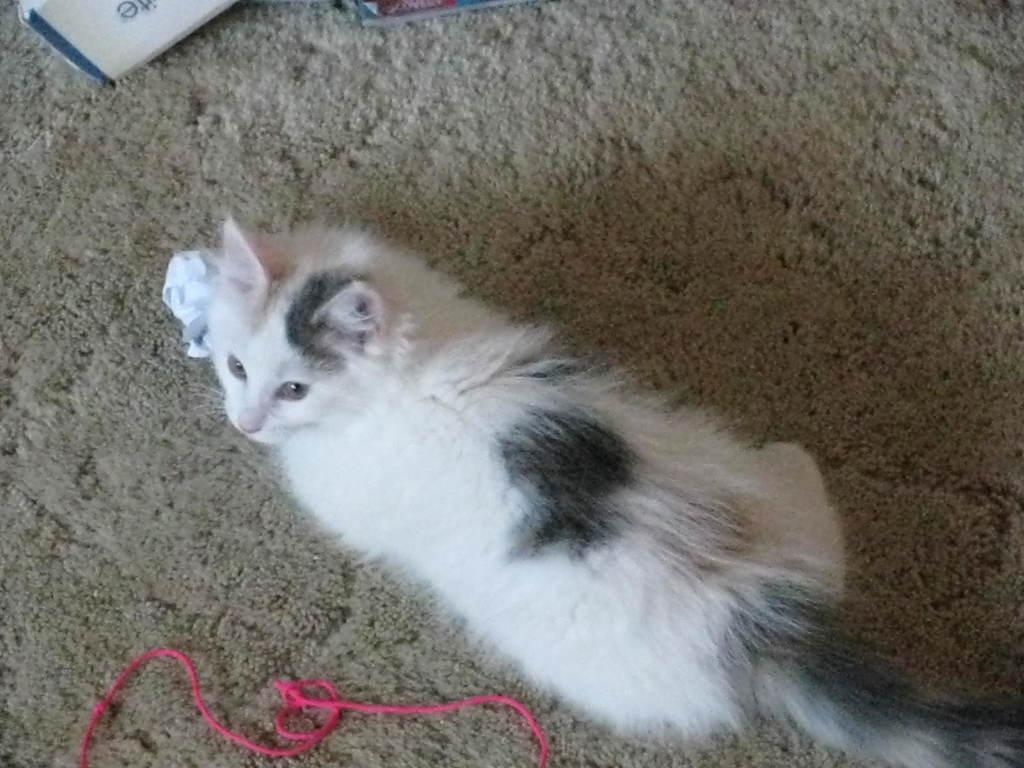What type of animal can be seen in the image? There is a cat in the image. Where is the cat located? The cat is sitting on a carpet. What other object is visible in the image? There is a pink rope in the image. Can you describe any other objects present in the image? There are other objects present in the image, but their specific details are not mentioned in the provided facts. What type of insect can be seen on the cat's lip in the image? There is no insect or lip present on the cat in the image. What color is the tooth that the cat is holding in the image? There is no tooth present in the image. 